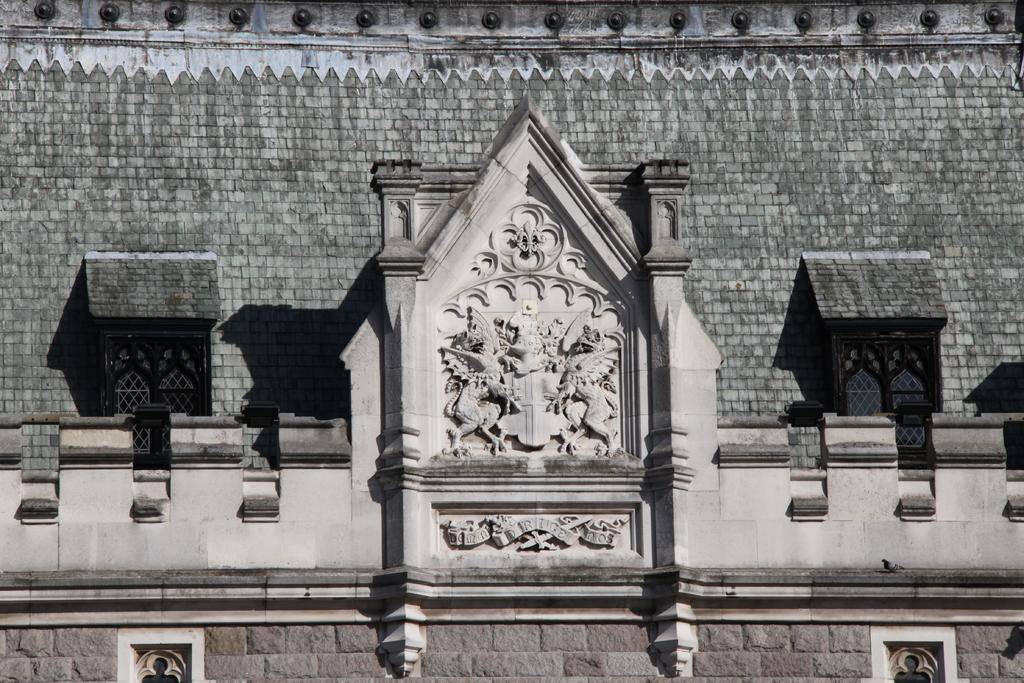What is the main structure in the image? There is a building in the image. Are there any other objects or features near the building? Yes, there are statues near the building. What colors are predominant in the building? The building is in grey and ash color. What type of eggnog is being served in the image? There is no eggnog present in the image; it features a building and statues. What box is used to store the facts in the image? There is no box or mention of facts in the image; it only shows a building and statues. 